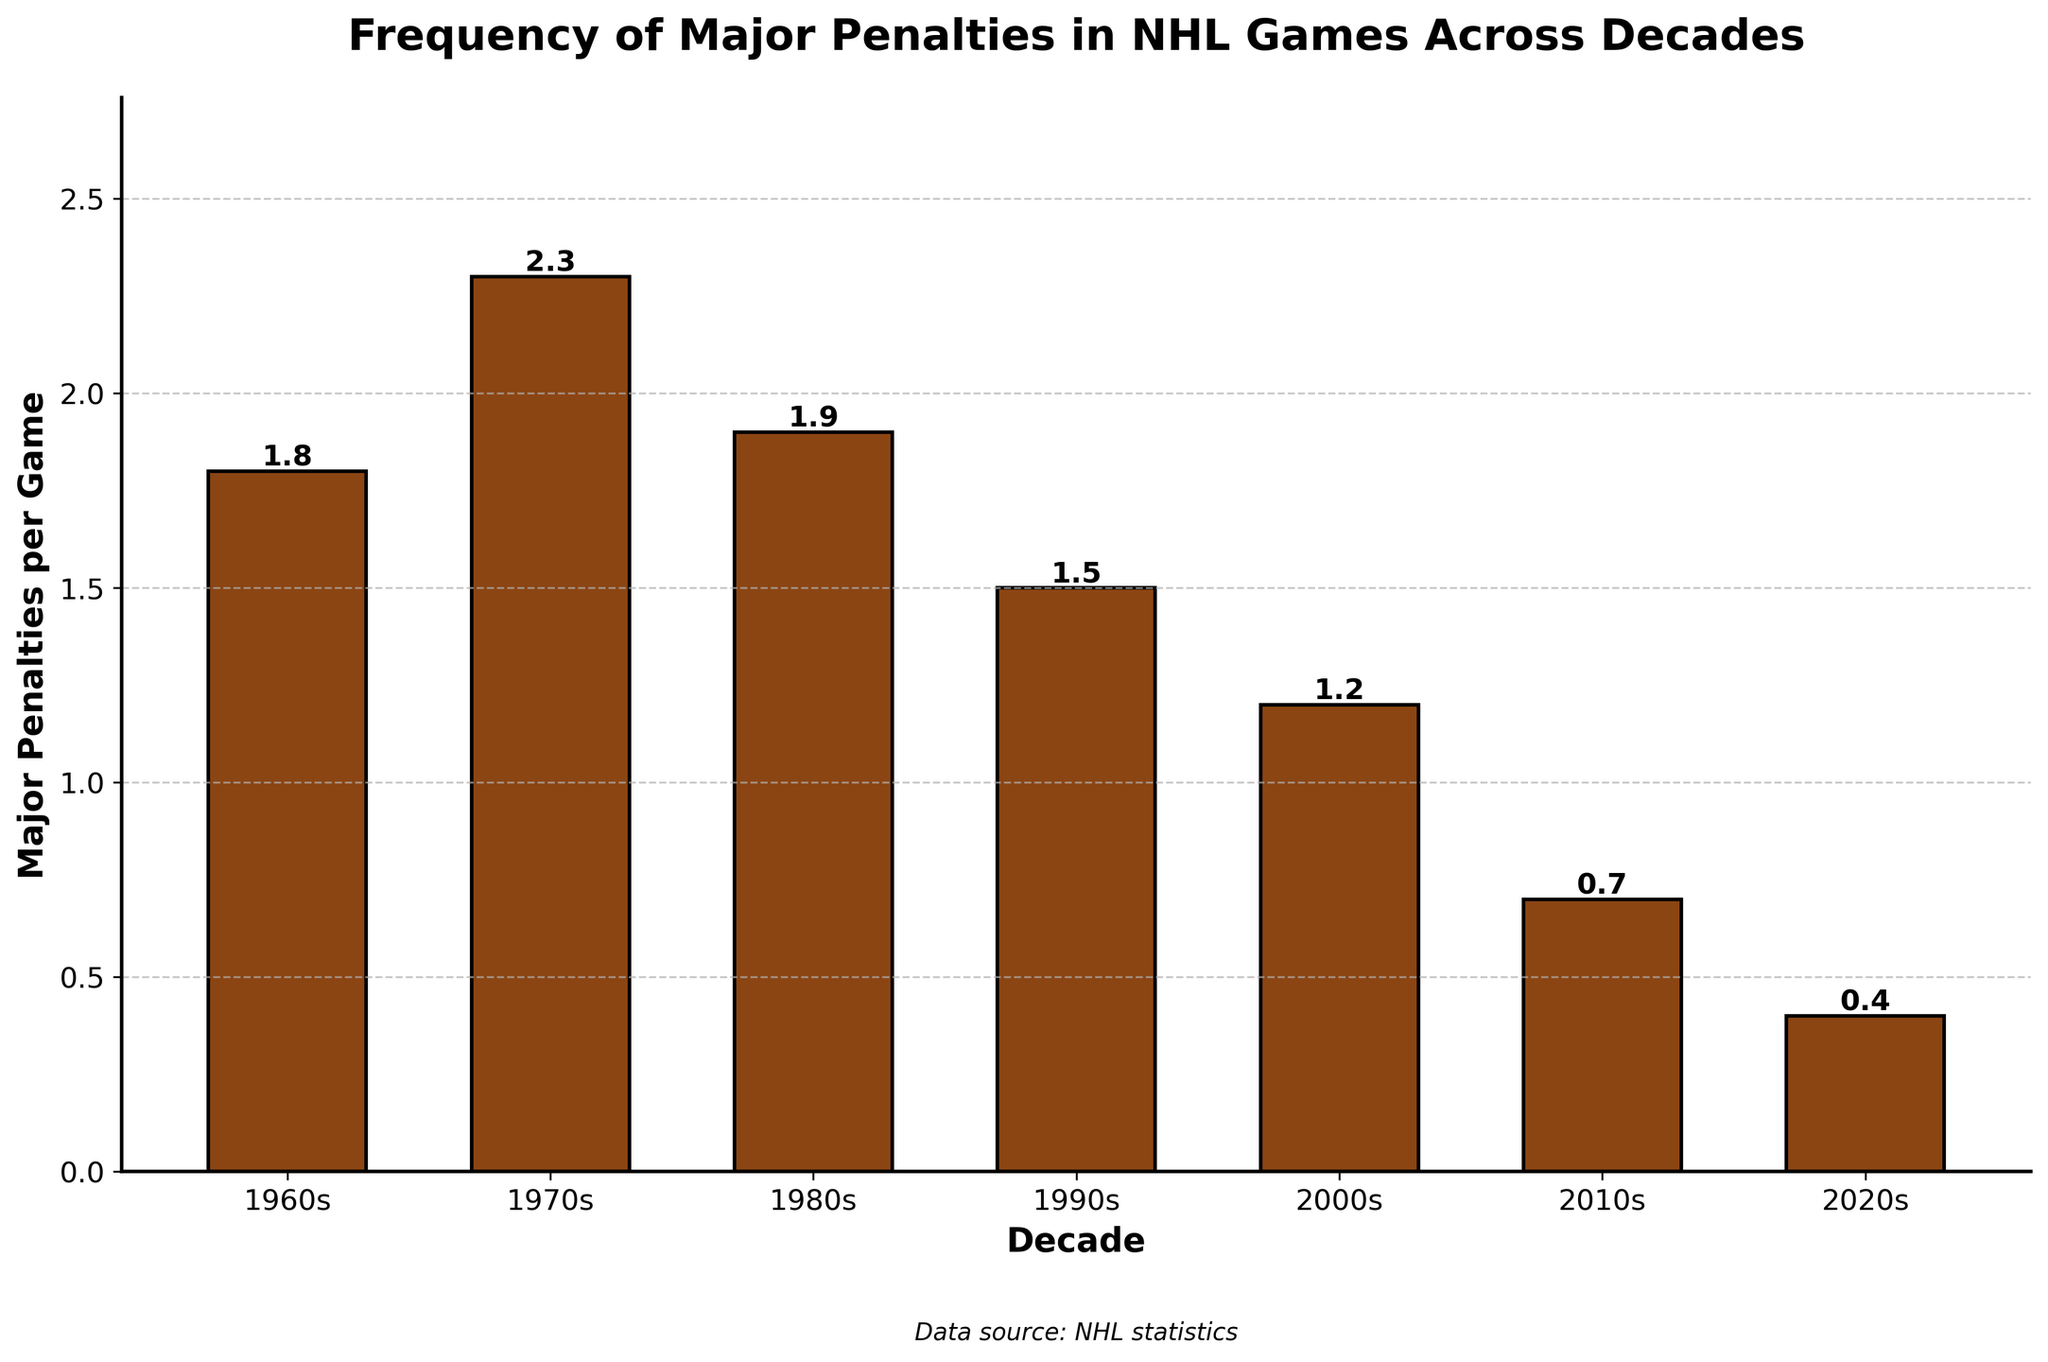Which decade had the highest frequency of major penalties per game? According to the figure, the highest bar represents the 1970s. This decade had the tallest bar, indicating the highest frequency of 2.3 major penalties per game.
Answer: 1970s Which decade had the lowest frequency of major penalties per game? The figure shows that the shortest bar is from the 2020s. Specifically, the height is 0.4, which is the lowest among all decades.
Answer: 2020s How has the frequency of major penalties changed from the 1960s to the 2020s? To assess the change, compare the heights of the bars from the 1960s (1.8) to the 2020s (0.4). The frequency has decreased from 1.8 to 0.4, indicating a decline.
Answer: Decreased By how much did the frequency of major penalties per game differ between the 1980s and 1990s? Subtract the value for the 1990s (1.5) from the value for the 1980s (1.9). The difference is 1.9 - 1.5 = 0.4.
Answer: 0.4 What is the total frequency of major penalties per game if you sum across all decades presented? Add the values of all decades: 1.8 (1960s) + 2.3 (1970s) + 1.9 (1980s) + 1.5 (1990s) + 1.2 (2000s) + 0.7 (2010s) + 0.4 (2020s). The total sum is 9.8.
Answer: 9.8 What is the average frequency of major penalties per game across the provided decades? First, compute the total frequency, which is 9.8. Then, divide this by the number of decades, which is 7. So, the average is 9.8 / 7 = 1.4.
Answer: 1.4 Has the trend in the frequency of major penalties per game increased or decreased over the decades? From the highest value in the 1970s (2.3) to each subsequent value down to 0.4 in the 2020s, there is a consistent downward trend.
Answer: Decreased Compare the frequency of major penalties per game between the 1970s and the 2000s. By how much is the value different, and which decade is higher? The value for the 1970s is 2.3 and for the 2000s is 1.2. Subtract 1.2 from 2.3 to get the difference: 2.3 - 1.2 = 1.1. The 1970s are higher.
Answer: 1.1, 1970s Out of all the visual attributes, which decade's bar is the shortest? Visually inspecting the figure, the shortest bar is from the 2020s, having the lowest height of 0.4.
Answer: 2020s 